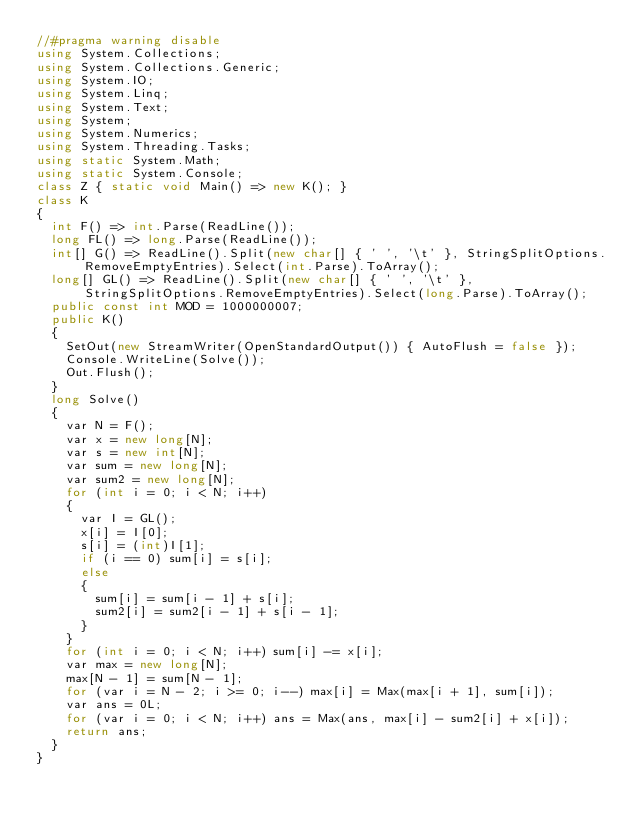Convert code to text. <code><loc_0><loc_0><loc_500><loc_500><_C#_>//#pragma warning disable
using System.Collections;
using System.Collections.Generic;
using System.IO;
using System.Linq;
using System.Text;
using System;
using System.Numerics;
using System.Threading.Tasks;
using static System.Math;
using static System.Console;
class Z { static void Main() => new K(); }
class K
{
	int F() => int.Parse(ReadLine());
	long FL() => long.Parse(ReadLine());
	int[] G() => ReadLine().Split(new char[] { ' ', '\t' }, StringSplitOptions.RemoveEmptyEntries).Select(int.Parse).ToArray();
	long[] GL() => ReadLine().Split(new char[] { ' ', '\t' }, StringSplitOptions.RemoveEmptyEntries).Select(long.Parse).ToArray();
	public const int MOD = 1000000007;
	public K()
	{
		SetOut(new StreamWriter(OpenStandardOutput()) { AutoFlush = false });
		Console.WriteLine(Solve());
		Out.Flush();
	}
	long Solve()
	{
		var N = F();
		var x = new long[N];
		var s = new int[N];
		var sum = new long[N];
		var sum2 = new long[N];
		for (int i = 0; i < N; i++)
		{
			var I = GL();
			x[i] = I[0];
			s[i] = (int)I[1];
			if (i == 0) sum[i] = s[i];
			else
			{
				sum[i] = sum[i - 1] + s[i];
				sum2[i] = sum2[i - 1] + s[i - 1];
			}
		}
		for (int i = 0; i < N; i++) sum[i] -= x[i];
		var max = new long[N];
		max[N - 1] = sum[N - 1];
		for (var i = N - 2; i >= 0; i--) max[i] = Max(max[i + 1], sum[i]);
		var ans = 0L;
		for (var i = 0; i < N; i++) ans = Max(ans, max[i] - sum2[i] + x[i]);
		return ans;
	}
}
</code> 